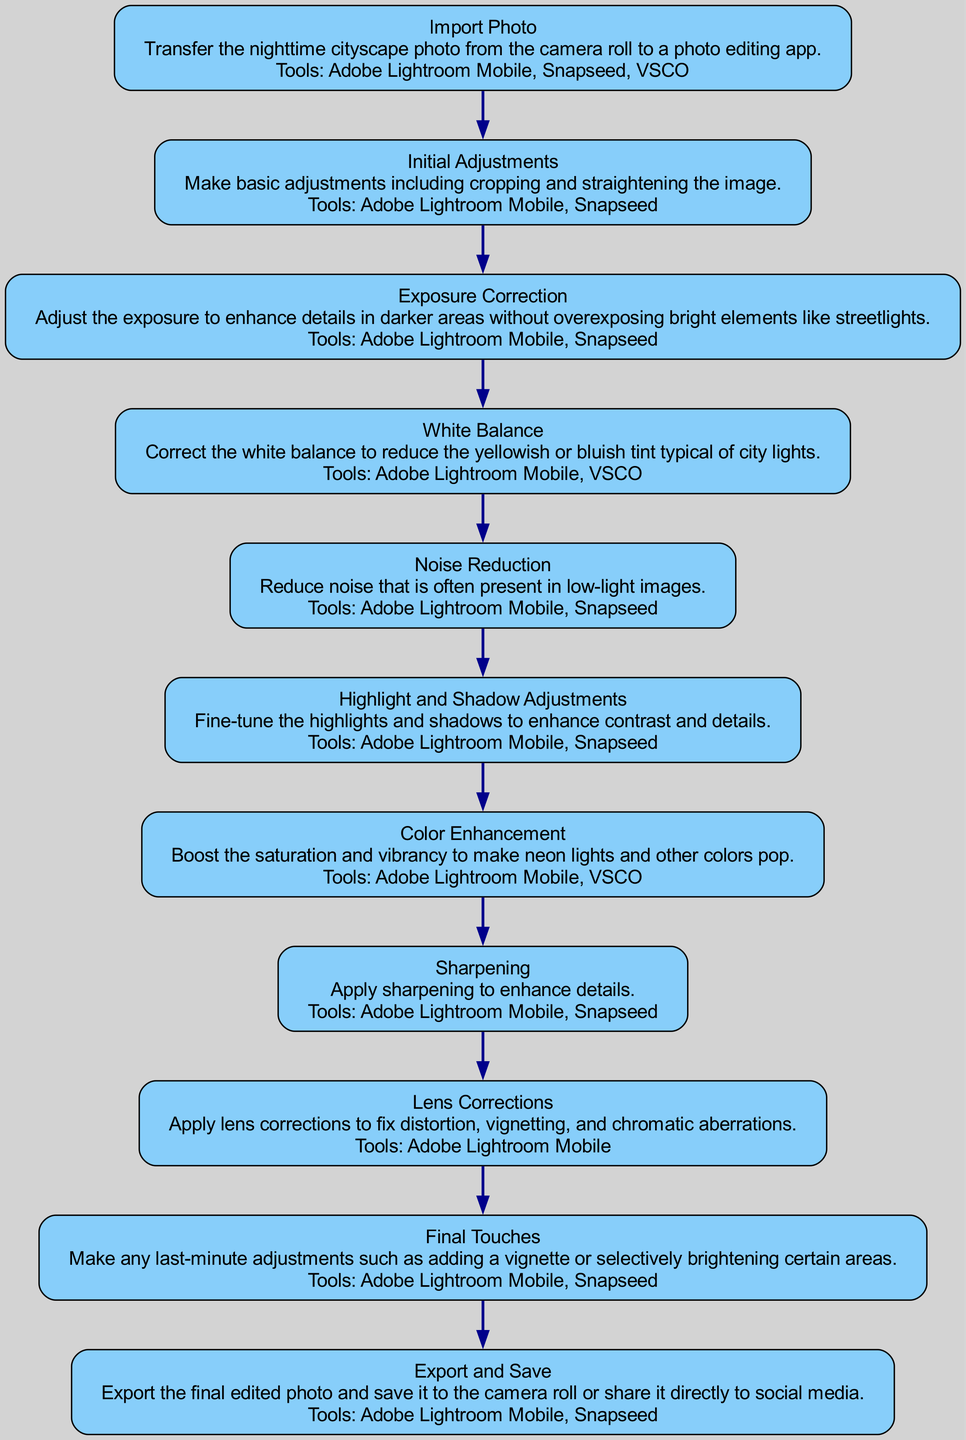What is the first step in the workflow? The first step in the workflow is labeled as "Import Photo," which indicates the beginning of the editing process. This step is crucial as it marks the transition from the source of the photo (the camera roll) to the editing phase in the app.
Answer: Import Photo How many total steps are in the workflow? By counting the nodes in the diagram, there are a total of 11 steps. Each node represents a specific action or process in the overall editing workflow.
Answer: 11 What tools are used in the "Exposure Correction" step? In the "Exposure Correction" step, the tools listed are "Adobe Lightroom Mobile" and "Snapseed." These tools are commonly employed for making adjustments to exposure in photos.
Answer: Adobe Lightroom Mobile, Snapseed What does the final step lead to? The final step, "Export and Save," leads to the conclusion of the workflow, representing the final stage where the edited photo is either saved to the camera roll or shared to social media. This signifies the end of the editing process.
Answer: End of the workflow Which step involves reducing noise in images? The step that involves reducing noise in images is "Noise Reduction." This step is significant in improving the overall quality of nighttime cityscape photographs, which often contain unwanted noise due to low light conditions.
Answer: Noise Reduction What is the purpose of the "White Balance" step? The purpose of the "White Balance" step is to correct the color balance in the photo, particularly to reduce any yellowish or bluish tint that might be present. This adjustment ensures that the colors in the image appear more natural.
Answer: Correct color balance Which editing tool is used in the most steps? The tool that appears most frequently across the steps is "Adobe Lightroom Mobile." This tool is utilized in multiple steps of the editing workflow, showcasing its versatility for various adjustments needed in nighttime photography.
Answer: Adobe Lightroom Mobile What is the overall goal of the workflow? The overall goal of the workflow is to enhance and prepare nighttime cityscape photographs for sharing or storage by applying a series of systematic editing steps. Each step is designed to improve different aspects of the image.
Answer: Enhance and prepare photographs What would happen after the "Highlight and Shadow Adjustments" step? Following the "Highlight and Shadow Adjustments" step, the next step is "Color Enhancement," which focuses on boosting saturation and vibrancy, further refining the image after adjusting its tonal ranges.
Answer: Color Enhancement 